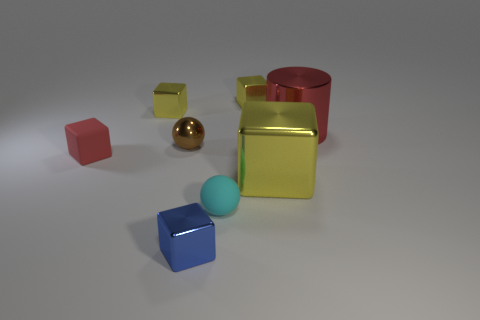Subtract all matte cubes. How many cubes are left? 4 Subtract all yellow blocks. How many blocks are left? 2 Subtract all balls. How many objects are left? 6 Subtract 1 cylinders. How many cylinders are left? 0 Add 4 tiny shiny objects. How many tiny shiny objects exist? 8 Add 1 large yellow metal blocks. How many objects exist? 9 Subtract 0 gray blocks. How many objects are left? 8 Subtract all gray cubes. Subtract all yellow balls. How many cubes are left? 5 Subtract all brown balls. How many red cubes are left? 1 Subtract all small yellow metal things. Subtract all rubber balls. How many objects are left? 5 